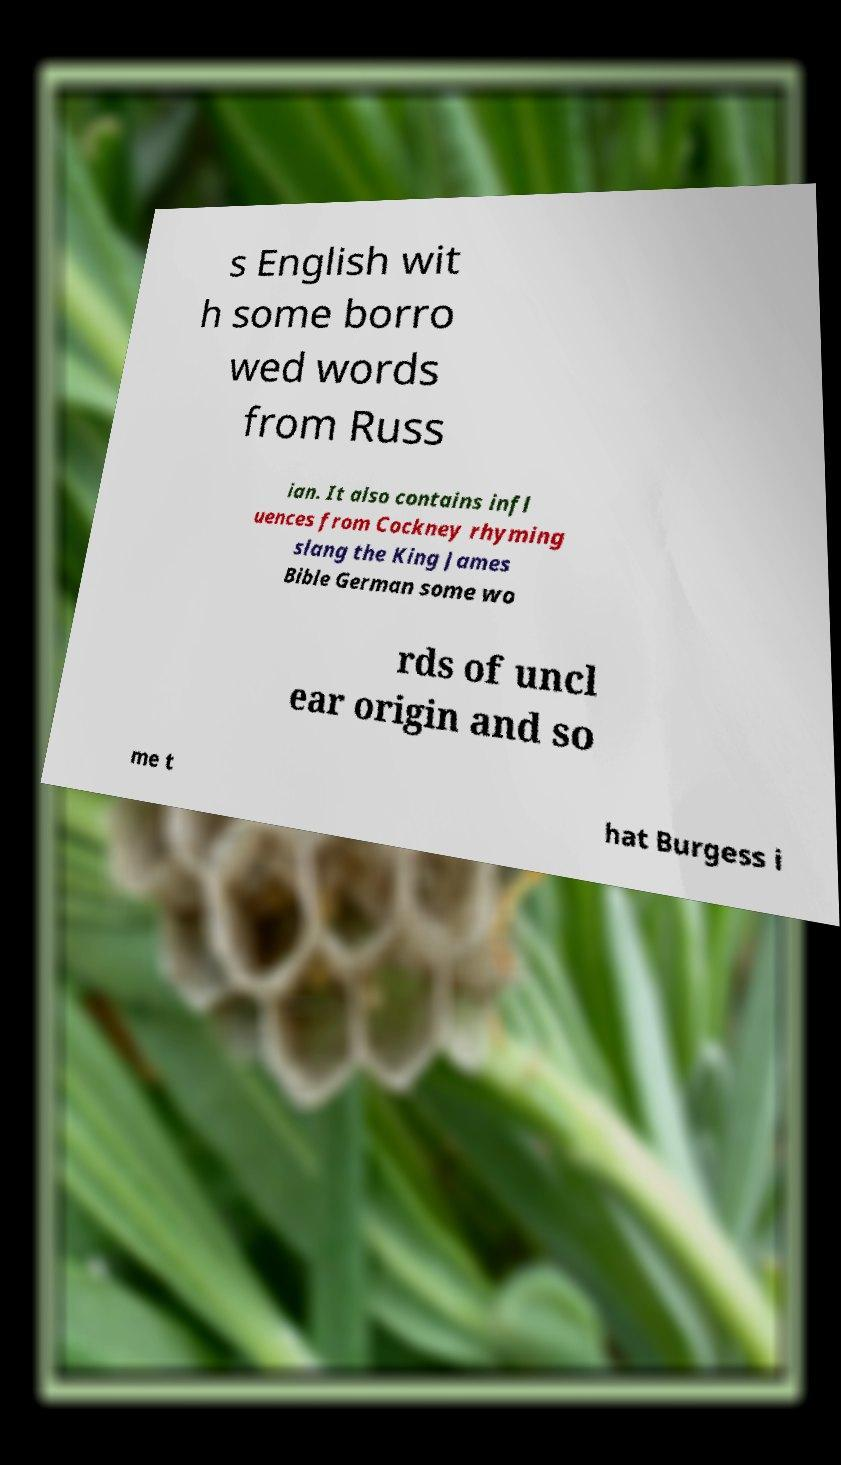Please read and relay the text visible in this image. What does it say? s English wit h some borro wed words from Russ ian. It also contains infl uences from Cockney rhyming slang the King James Bible German some wo rds of uncl ear origin and so me t hat Burgess i 